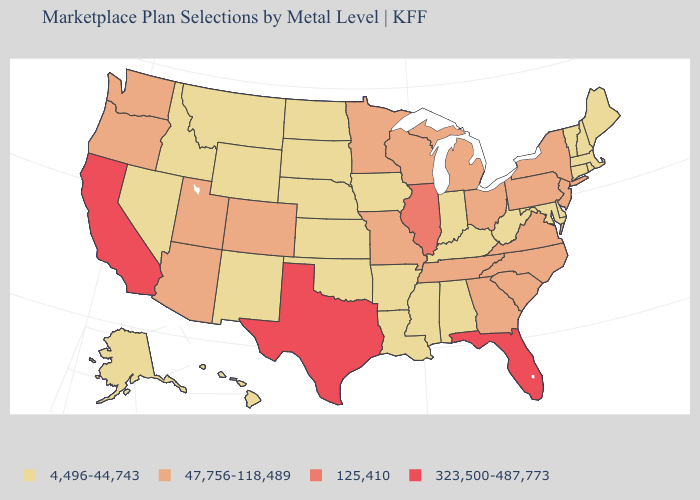Among the states that border Maine , which have the lowest value?
Quick response, please. New Hampshire. Which states have the lowest value in the South?
Give a very brief answer. Alabama, Arkansas, Delaware, Kentucky, Louisiana, Maryland, Mississippi, Oklahoma, West Virginia. What is the lowest value in the USA?
Give a very brief answer. 4,496-44,743. Is the legend a continuous bar?
Answer briefly. No. Does Rhode Island have a lower value than Arkansas?
Give a very brief answer. No. Name the states that have a value in the range 323,500-487,773?
Give a very brief answer. California, Florida, Texas. Which states have the lowest value in the USA?
Answer briefly. Alabama, Alaska, Arkansas, Connecticut, Delaware, Hawaii, Idaho, Indiana, Iowa, Kansas, Kentucky, Louisiana, Maine, Maryland, Massachusetts, Mississippi, Montana, Nebraska, Nevada, New Hampshire, New Mexico, North Dakota, Oklahoma, Rhode Island, South Dakota, Vermont, West Virginia, Wyoming. Name the states that have a value in the range 47,756-118,489?
Concise answer only. Arizona, Colorado, Georgia, Michigan, Minnesota, Missouri, New Jersey, New York, North Carolina, Ohio, Oregon, Pennsylvania, South Carolina, Tennessee, Utah, Virginia, Washington, Wisconsin. Name the states that have a value in the range 323,500-487,773?
Quick response, please. California, Florida, Texas. What is the value of Delaware?
Give a very brief answer. 4,496-44,743. Does the map have missing data?
Short answer required. No. What is the highest value in the USA?
Concise answer only. 323,500-487,773. What is the value of California?
Keep it brief. 323,500-487,773. What is the highest value in the Northeast ?
Concise answer only. 47,756-118,489. What is the value of North Carolina?
Quick response, please. 47,756-118,489. 